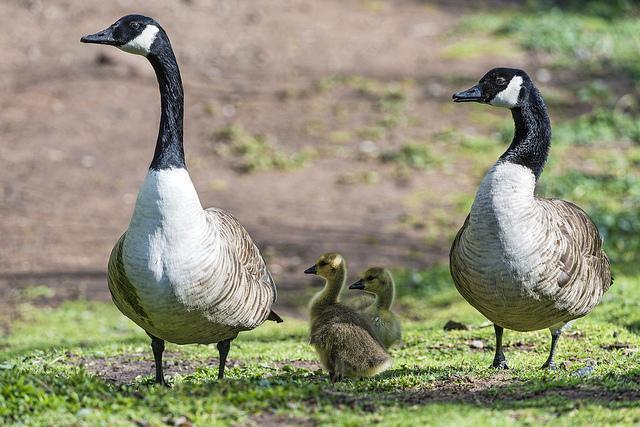How many birds are there?
Give a very brief answer. 4. How many men are in the image?
Give a very brief answer. 0. 